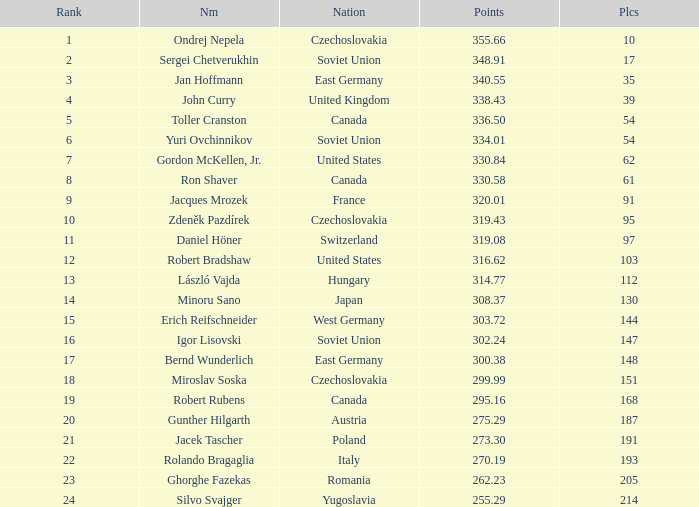Which Rank has a Name of john curry, and Points larger than 338.43? None. 